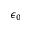<formula> <loc_0><loc_0><loc_500><loc_500>\epsilon _ { 0 }</formula> 